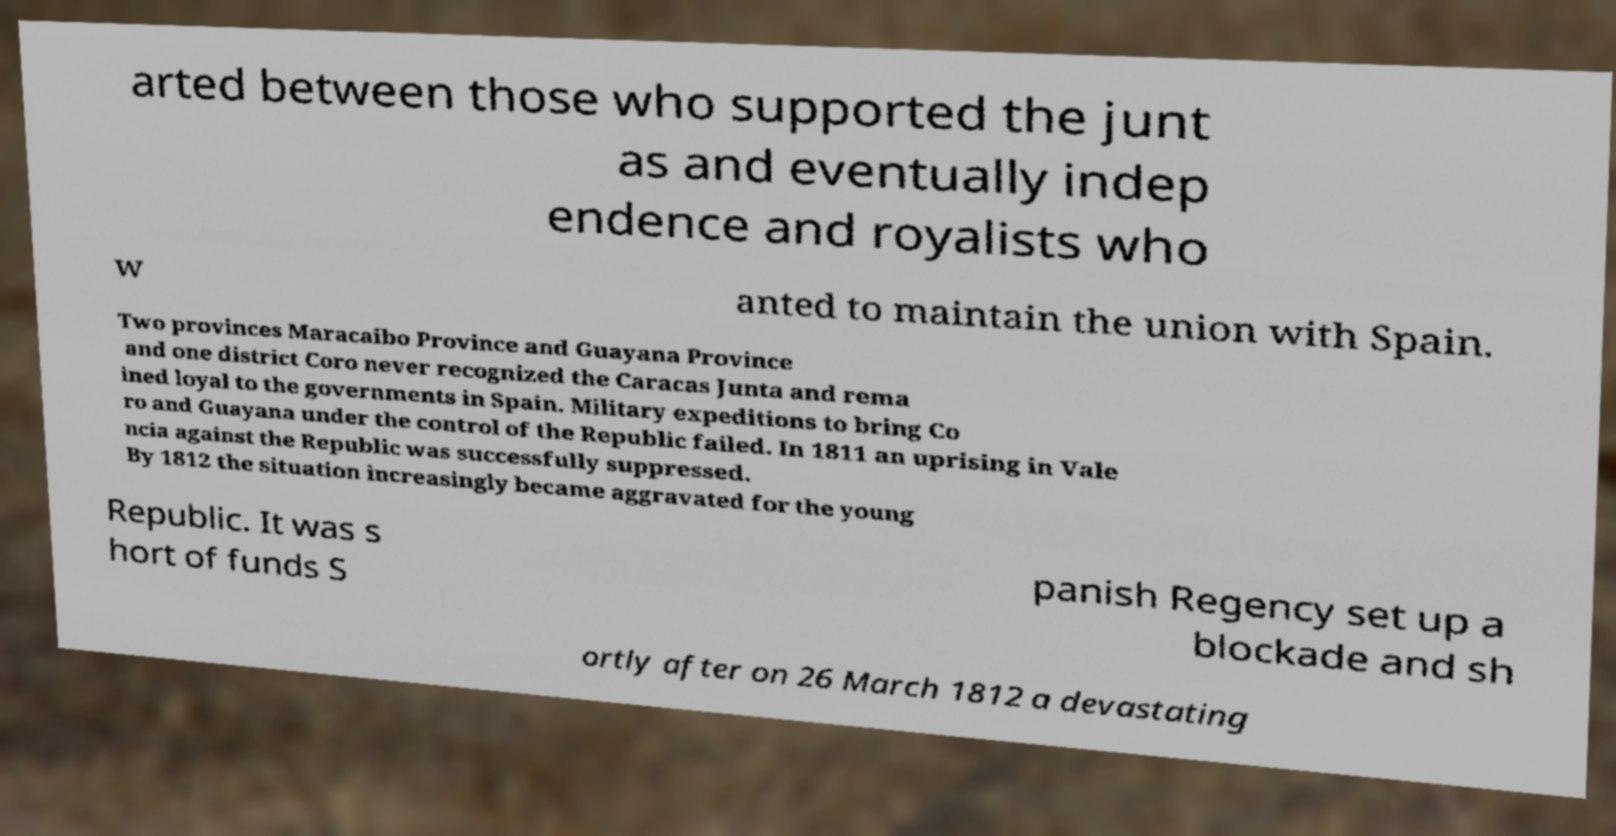Can you read and provide the text displayed in the image?This photo seems to have some interesting text. Can you extract and type it out for me? arted between those who supported the junt as and eventually indep endence and royalists who w anted to maintain the union with Spain. Two provinces Maracaibo Province and Guayana Province and one district Coro never recognized the Caracas Junta and rema ined loyal to the governments in Spain. Military expeditions to bring Co ro and Guayana under the control of the Republic failed. In 1811 an uprising in Vale ncia against the Republic was successfully suppressed. By 1812 the situation increasingly became aggravated for the young Republic. It was s hort of funds S panish Regency set up a blockade and sh ortly after on 26 March 1812 a devastating 